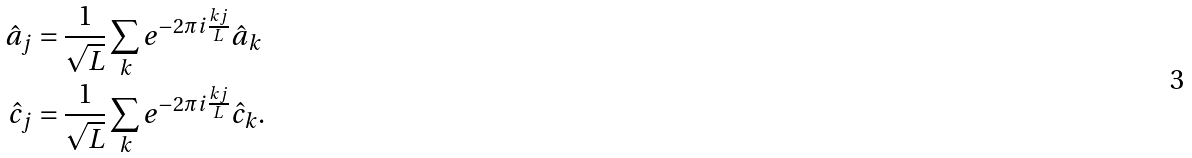<formula> <loc_0><loc_0><loc_500><loc_500>\hat { a } _ { j } & = \frac { 1 } { \sqrt { L } } \sum _ { k } e ^ { - 2 \pi i \frac { k j } { L } } \hat { a } _ { k } \\ \hat { c } _ { j } & = \frac { 1 } { \sqrt { L } } \sum _ { k } e ^ { - 2 \pi i \frac { k j } { L } } \hat { c } _ { k } .</formula> 